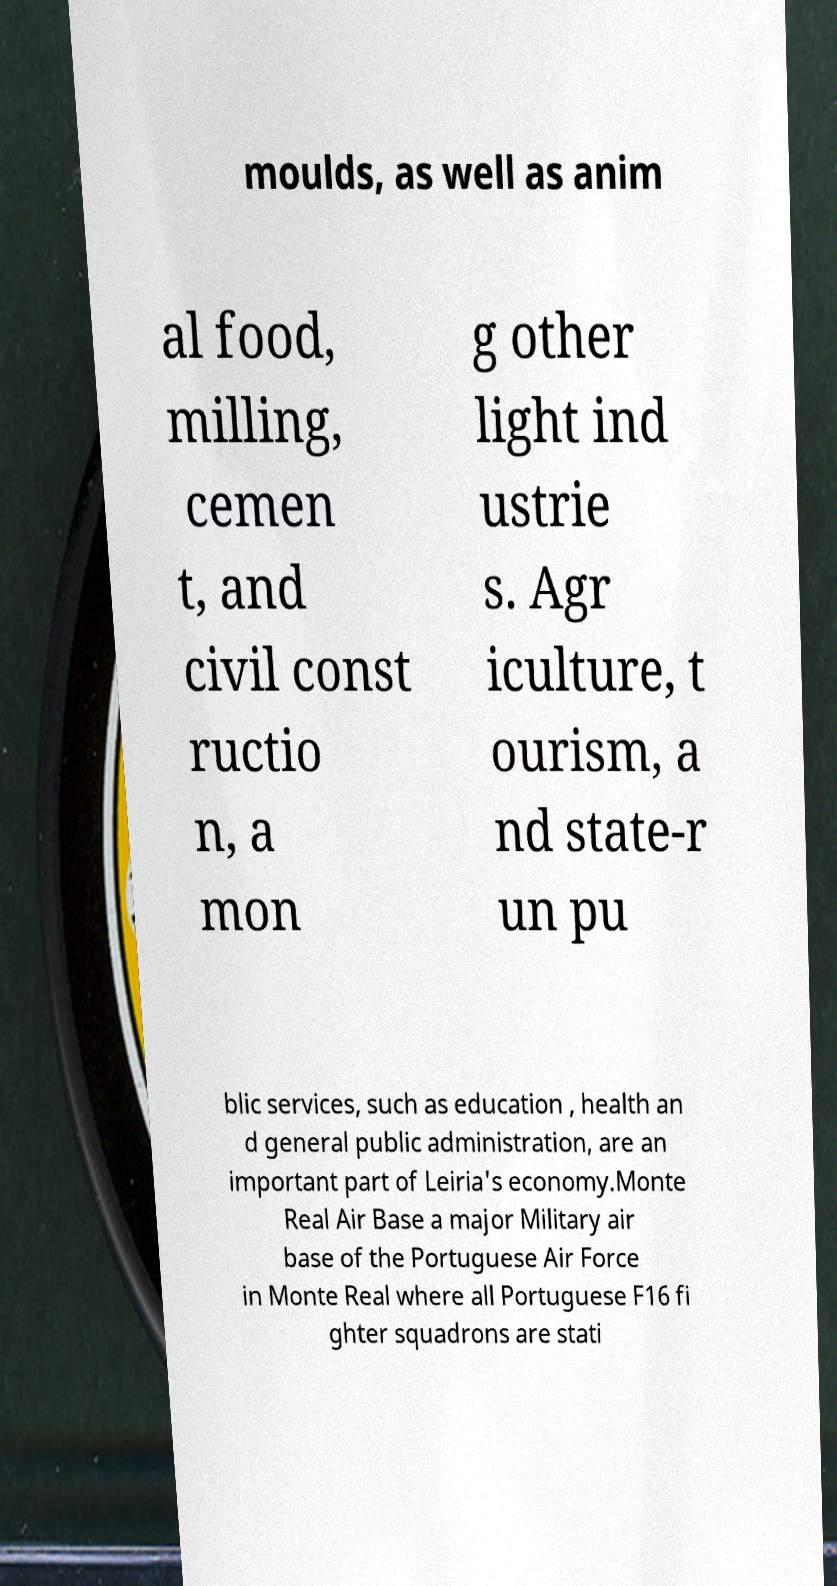For documentation purposes, I need the text within this image transcribed. Could you provide that? moulds, as well as anim al food, milling, cemen t, and civil const ructio n, a mon g other light ind ustrie s. Agr iculture, t ourism, a nd state-r un pu blic services, such as education , health an d general public administration, are an important part of Leiria's economy.Monte Real Air Base a major Military air base of the Portuguese Air Force in Monte Real where all Portuguese F16 fi ghter squadrons are stati 